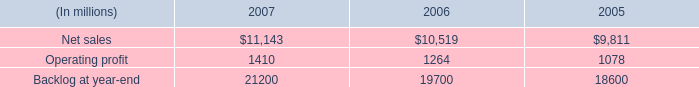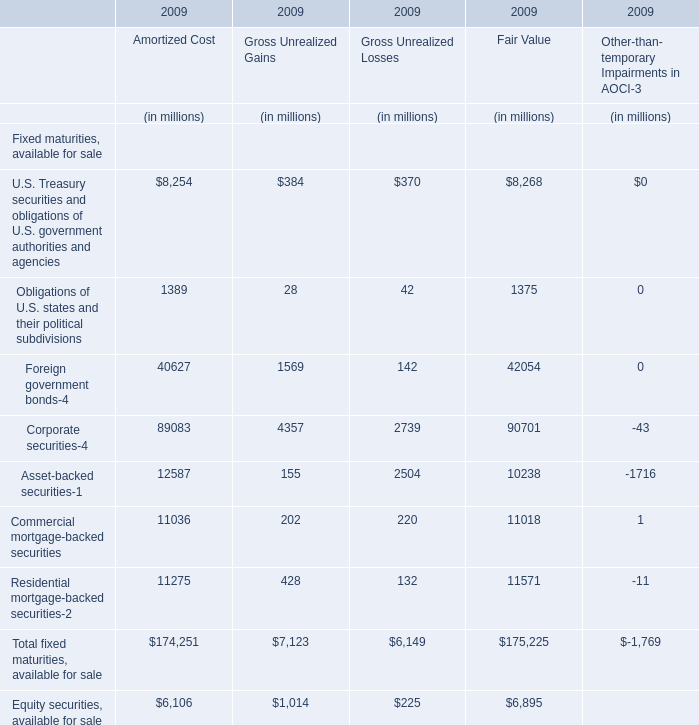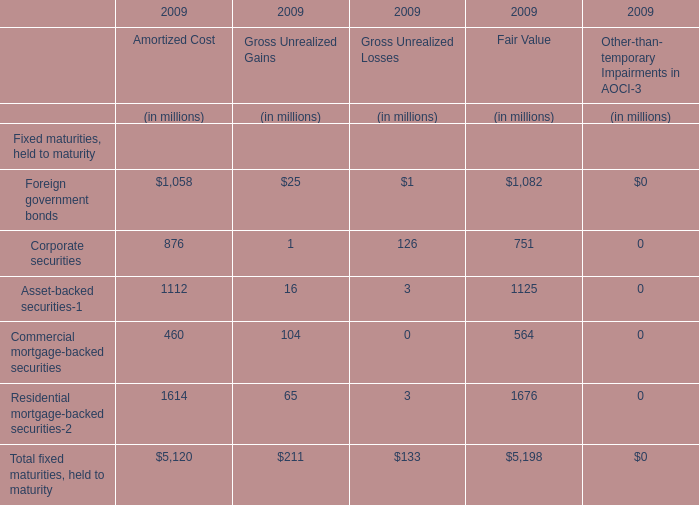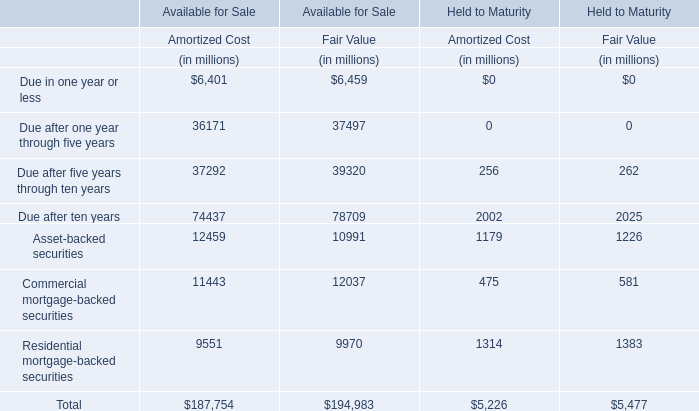what was the percentage change in backlog from 2006 to 2007? 
Computations: ((21200 - 19700) / 19700)
Answer: 0.07614. 